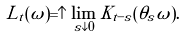<formula> <loc_0><loc_0><loc_500><loc_500>L _ { t } ( \omega ) = \uparrow \lim _ { s \downarrow 0 } \tilde { K } _ { t - s } ( \theta _ { s } \omega ) .</formula> 